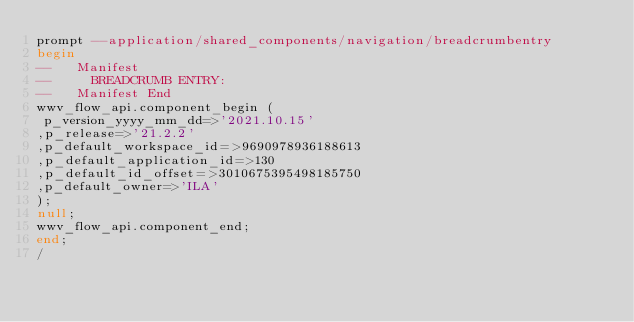<code> <loc_0><loc_0><loc_500><loc_500><_SQL_>prompt --application/shared_components/navigation/breadcrumbentry
begin
--   Manifest
--     BREADCRUMB ENTRY: 
--   Manifest End
wwv_flow_api.component_begin (
 p_version_yyyy_mm_dd=>'2021.10.15'
,p_release=>'21.2.2'
,p_default_workspace_id=>9690978936188613
,p_default_application_id=>130
,p_default_id_offset=>3010675395498185750
,p_default_owner=>'ILA'
);
null;
wwv_flow_api.component_end;
end;
/
</code> 